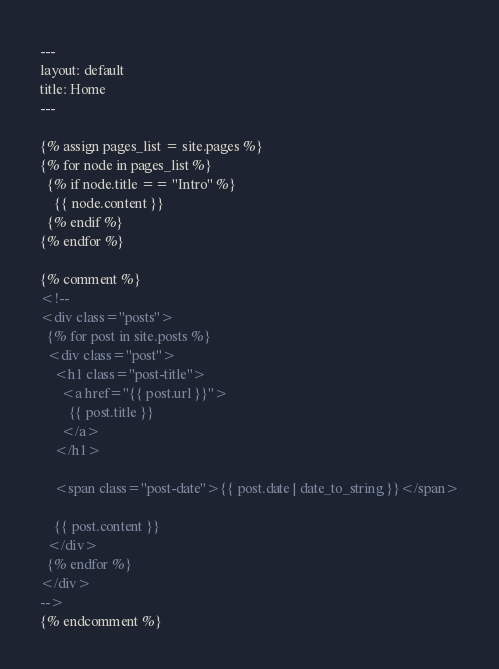Convert code to text. <code><loc_0><loc_0><loc_500><loc_500><_HTML_>---
layout: default
title: Home
---

{% assign pages_list = site.pages %}
{% for node in pages_list %}
  {% if node.title == "Intro" %}
    {{ node.content }}
  {% endif %}
{% endfor %}

{% comment %}
<!--
<div class="posts">
  {% for post in site.posts %}
  <div class="post">
    <h1 class="post-title">
      <a href="{{ post.url }}">
        {{ post.title }}
      </a>
    </h1>

    <span class="post-date">{{ post.date | date_to_string }}</span>

    {{ post.content }}
  </div>
  {% endfor %}
</div>
-->
{% endcomment %}</code> 